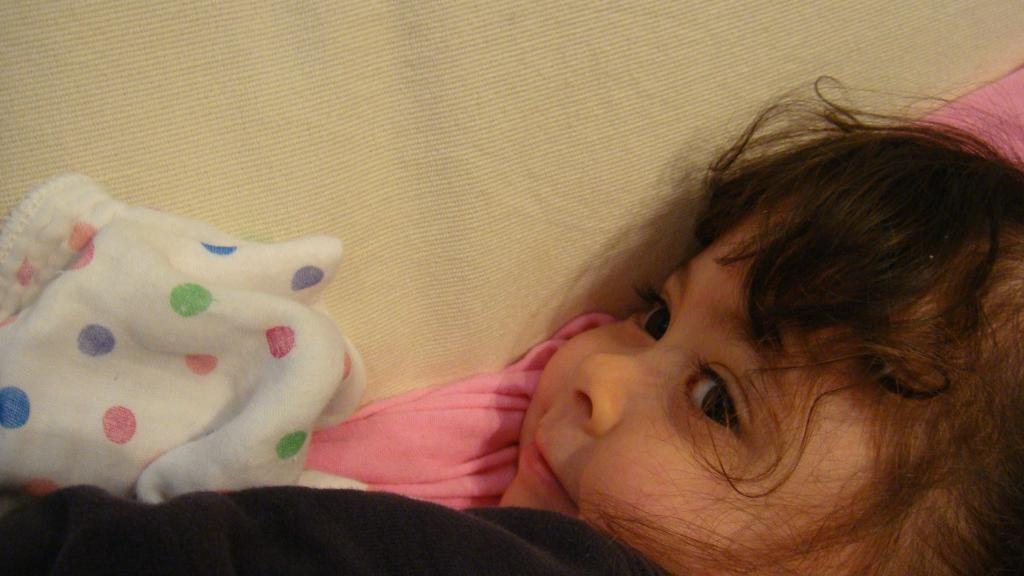What is the main subject of the image? The main subject of the image is a kid. What object is also visible in the image? There is a bed sheet in the image. What type of love note can be seen on the bed sheet in the image? There is no love note present on the bed sheet in the image. 